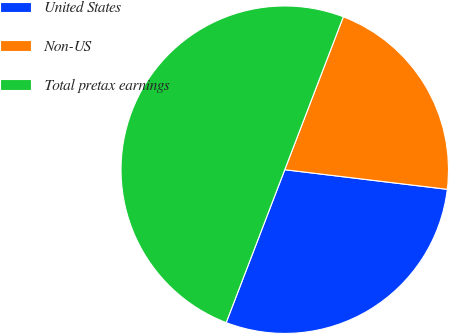Convert chart to OTSL. <chart><loc_0><loc_0><loc_500><loc_500><pie_chart><fcel>United States<fcel>Non-US<fcel>Total pretax earnings<nl><fcel>28.91%<fcel>21.09%<fcel>50.0%<nl></chart> 